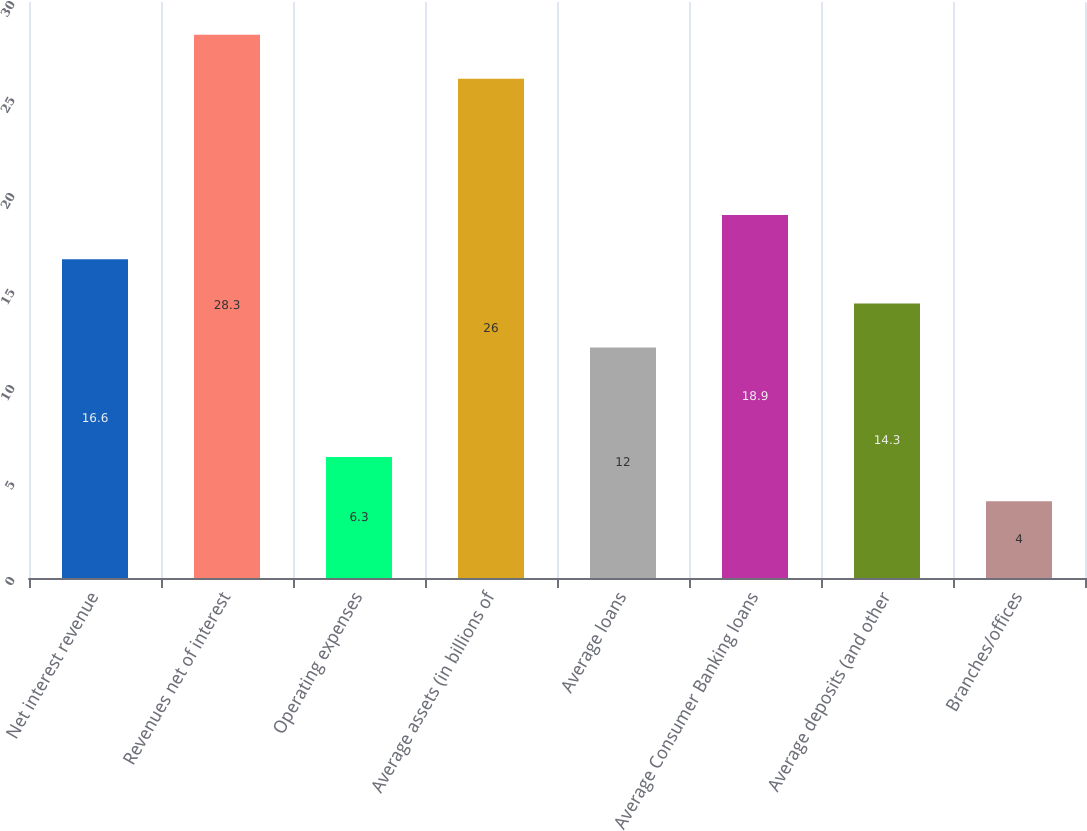Convert chart. <chart><loc_0><loc_0><loc_500><loc_500><bar_chart><fcel>Net interest revenue<fcel>Revenues net of interest<fcel>Operating expenses<fcel>Average assets (in billions of<fcel>Average loans<fcel>Average Consumer Banking loans<fcel>Average deposits (and other<fcel>Branches/offices<nl><fcel>16.6<fcel>28.3<fcel>6.3<fcel>26<fcel>12<fcel>18.9<fcel>14.3<fcel>4<nl></chart> 